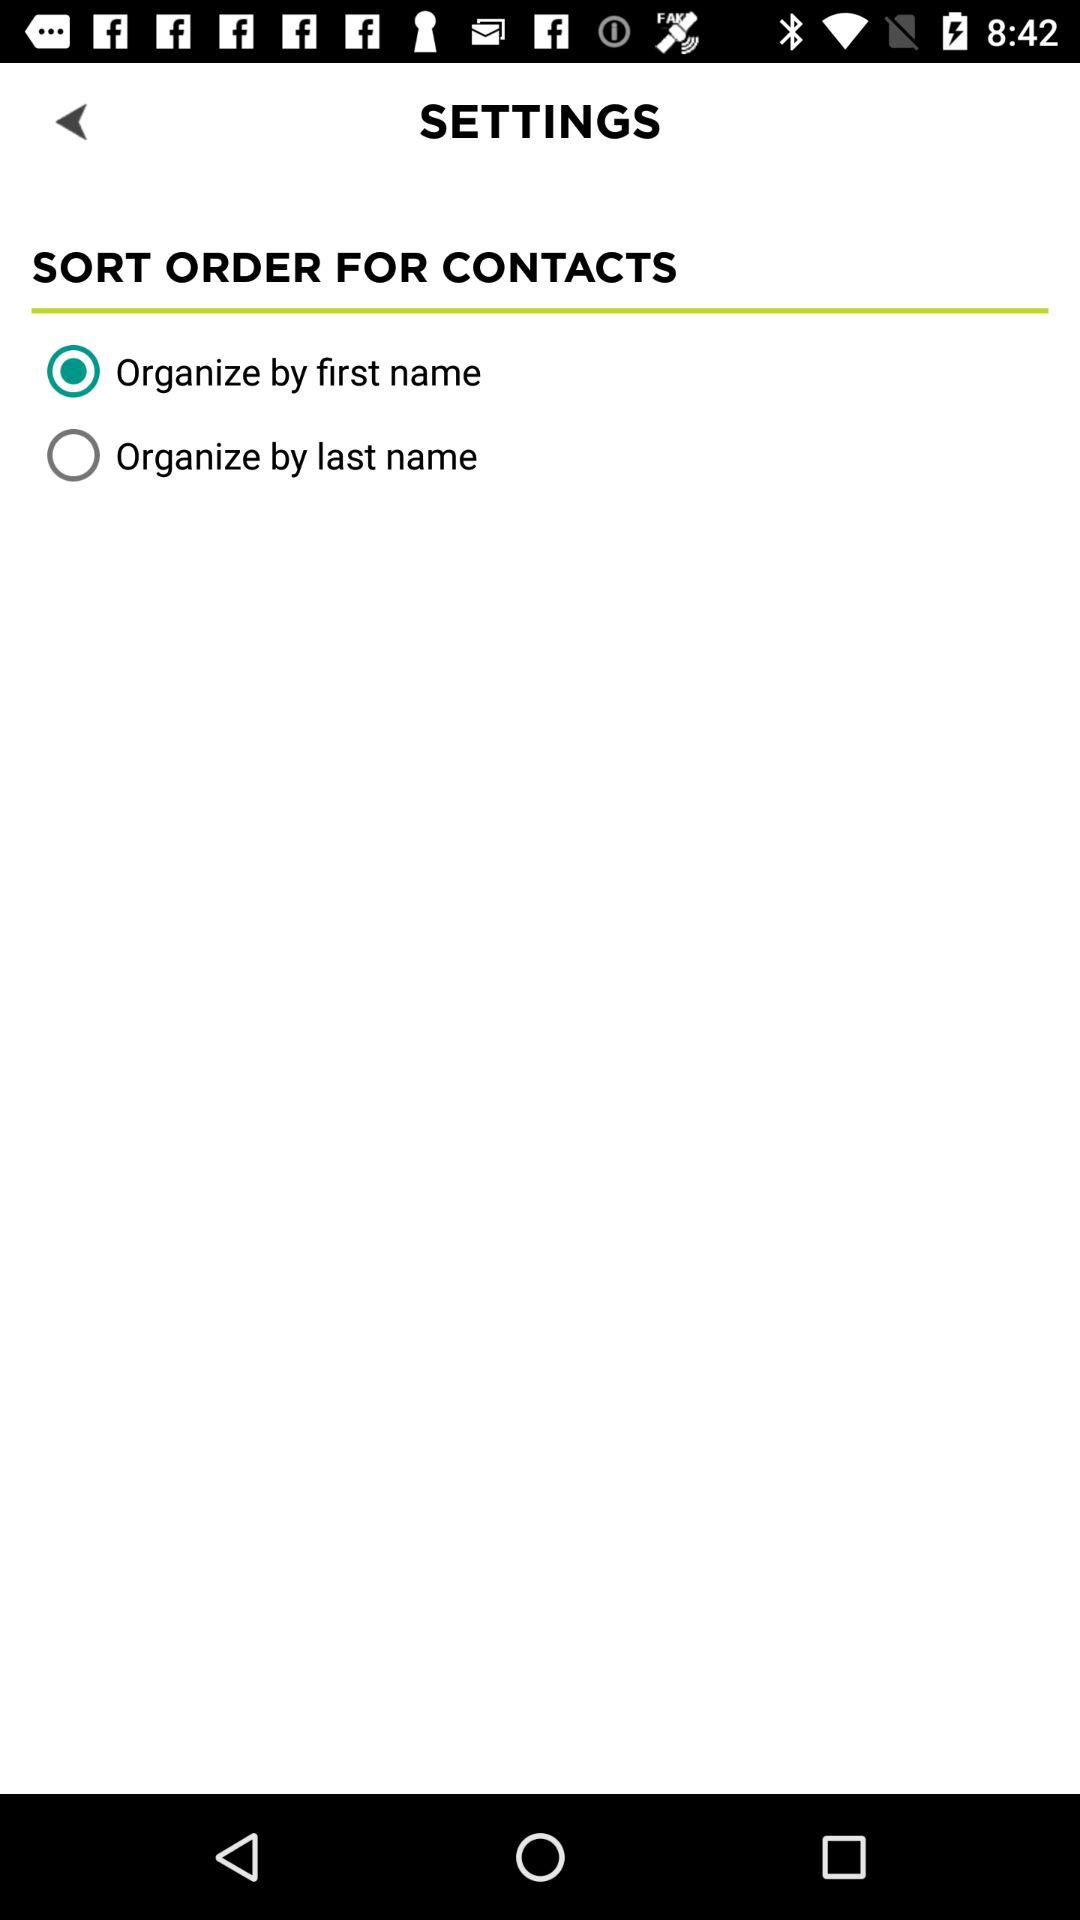Which option is selected for sorting the order of contacts? The selected option is "Organize by first name". 